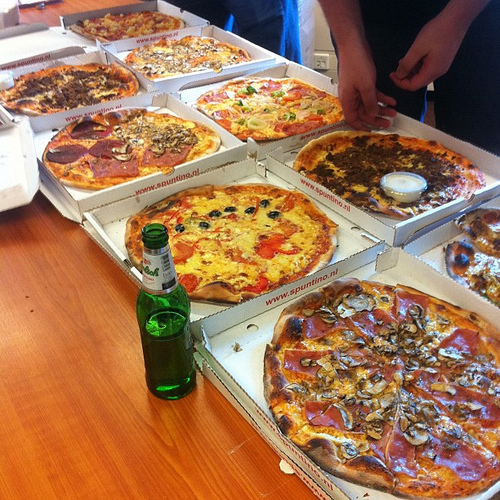Legend has it that one of these pizzas is enchanted. Using your keen observation, can you figure out which one? The enchanted pizza might be the one with the unusual glowing cheese in the center, which stands out and appears somewhat magical! If this enchanted pizza could grant you a single wish, what would it be? I would wish for endless knowledge and the ability to understand anything instantly, to help and solve even more complex problems for humanity. Let's imagine there's a secret doorway hidden under one of these pizzas. Which one do you think, and where does it lead? The secret doorway could be hidden under the pizza with the pepperoni slices spread out evenly. This hidden doorway might lead to an underground world where pizzaiolos (master pizza makers) are crafting the most amazing and innovative pizzas, with new flavors and ingredients from around the universe! 